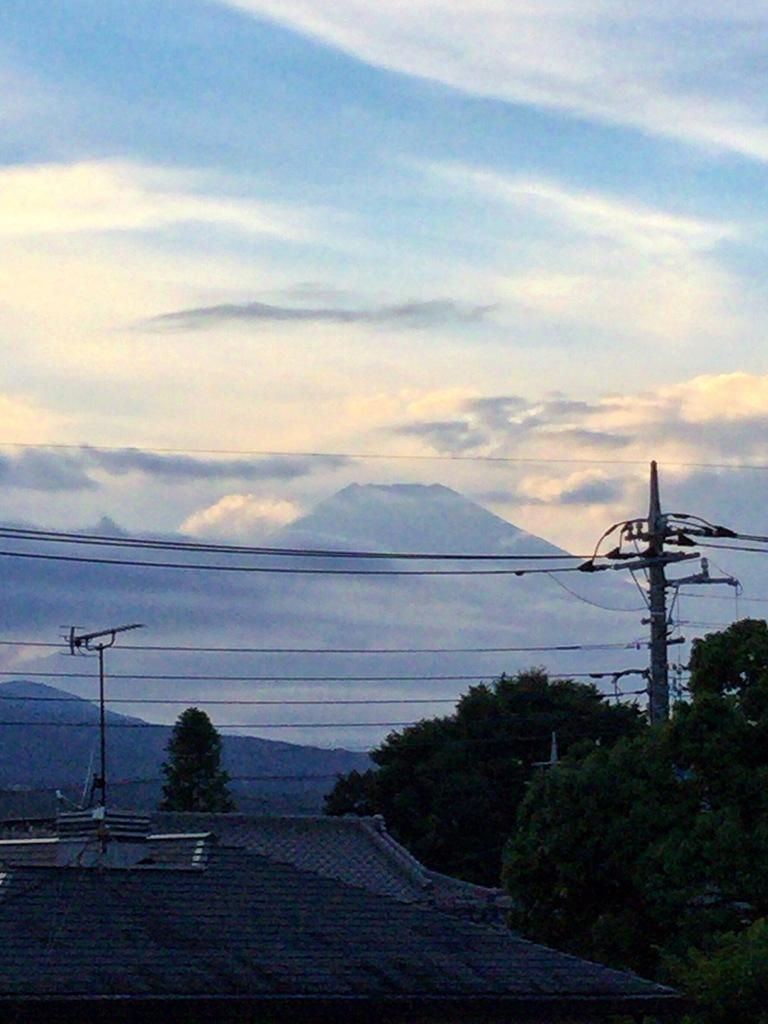What type of structures can be seen in the image? There are rooftops in the image. What else is present in the image besides rooftops? There are poles, wires, trees, and hills visible in the image. What can be seen in the background of the image? The sky is visible in the background of the image, with clouds present. Can you see a ghost running on the rooftops in the image? There is no ghost or running depicted in the image; it features rooftops, poles, wires, trees, hills, and a sky with clouds. 